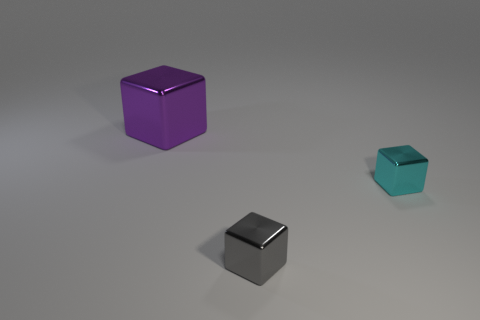Add 3 small cyan shiny cylinders. How many objects exist? 6 Add 3 tiny cyan shiny cubes. How many tiny cyan shiny cubes are left? 4 Add 3 large blocks. How many large blocks exist? 4 Subtract 1 gray cubes. How many objects are left? 2 Subtract all purple things. Subtract all gray metal things. How many objects are left? 1 